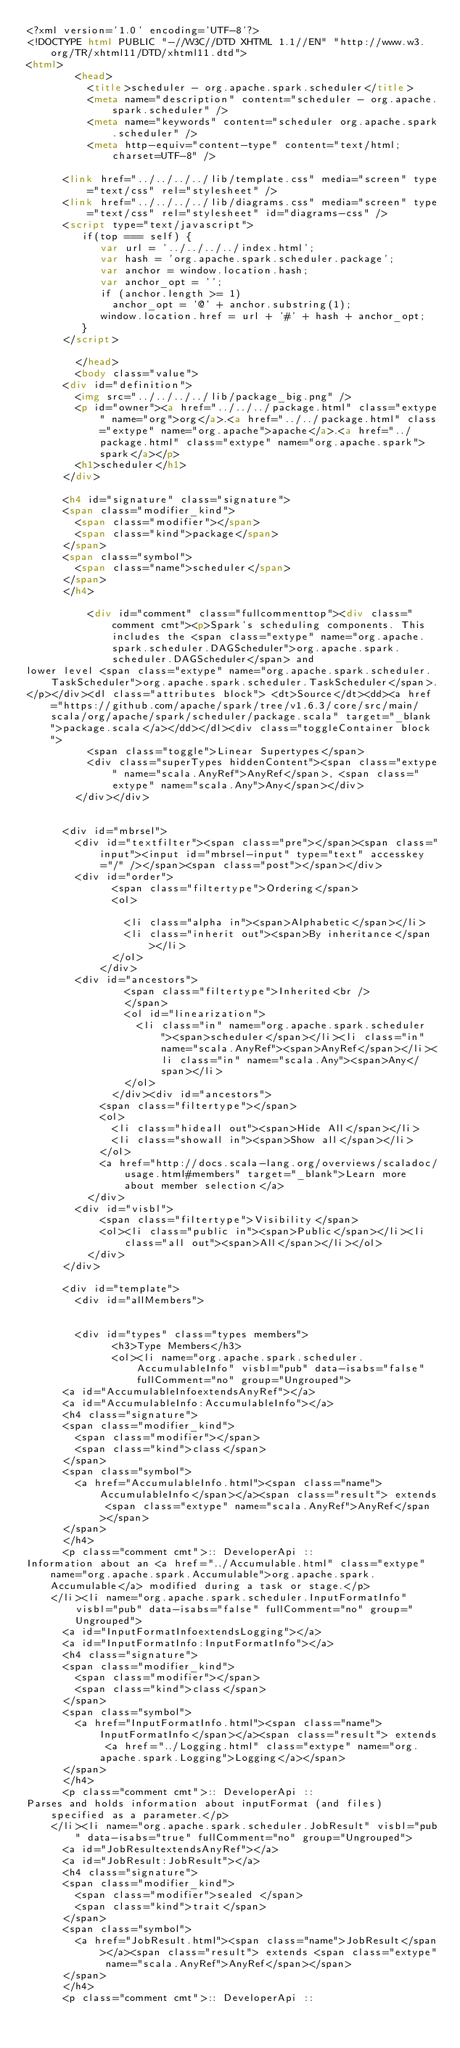Convert code to text. <code><loc_0><loc_0><loc_500><loc_500><_HTML_><?xml version='1.0' encoding='UTF-8'?>
<!DOCTYPE html PUBLIC "-//W3C//DTD XHTML 1.1//EN" "http://www.w3.org/TR/xhtml11/DTD/xhtml11.dtd">
<html>
        <head>
          <title>scheduler - org.apache.spark.scheduler</title>
          <meta name="description" content="scheduler - org.apache.spark.scheduler" />
          <meta name="keywords" content="scheduler org.apache.spark.scheduler" />
          <meta http-equiv="content-type" content="text/html; charset=UTF-8" />
          
      <link href="../../../../lib/template.css" media="screen" type="text/css" rel="stylesheet" />
      <link href="../../../../lib/diagrams.css" media="screen" type="text/css" rel="stylesheet" id="diagrams-css" />
      <script type="text/javascript">
         if(top === self) {
            var url = '../../../../index.html';
            var hash = 'org.apache.spark.scheduler.package';
            var anchor = window.location.hash;
            var anchor_opt = '';
            if (anchor.length >= 1)
              anchor_opt = '@' + anchor.substring(1);
            window.location.href = url + '#' + hash + anchor_opt;
         }
   	  </script>
    
        </head>
        <body class="value">
      <div id="definition">
        <img src="../../../../lib/package_big.png" />
        <p id="owner"><a href="../../../package.html" class="extype" name="org">org</a>.<a href="../../package.html" class="extype" name="org.apache">apache</a>.<a href="../package.html" class="extype" name="org.apache.spark">spark</a></p>
        <h1>scheduler</h1>
      </div>

      <h4 id="signature" class="signature">
      <span class="modifier_kind">
        <span class="modifier"></span>
        <span class="kind">package</span>
      </span>
      <span class="symbol">
        <span class="name">scheduler</span>
      </span>
      </h4>
      
          <div id="comment" class="fullcommenttop"><div class="comment cmt"><p>Spark's scheduling components. This includes the <span class="extype" name="org.apache.spark.scheduler.DAGScheduler">org.apache.spark.scheduler.DAGScheduler</span> and
lower level <span class="extype" name="org.apache.spark.scheduler.TaskScheduler">org.apache.spark.scheduler.TaskScheduler</span>.
</p></div><dl class="attributes block"> <dt>Source</dt><dd><a href="https://github.com/apache/spark/tree/v1.6.3/core/src/main/scala/org/apache/spark/scheduler/package.scala" target="_blank">package.scala</a></dd></dl><div class="toggleContainer block">
          <span class="toggle">Linear Supertypes</span>
          <div class="superTypes hiddenContent"><span class="extype" name="scala.AnyRef">AnyRef</span>, <span class="extype" name="scala.Any">Any</span></div>
        </div></div>
        

      <div id="mbrsel">
        <div id="textfilter"><span class="pre"></span><span class="input"><input id="mbrsel-input" type="text" accesskey="/" /></span><span class="post"></span></div>
        <div id="order">
              <span class="filtertype">Ordering</span>
              <ol>
                
                <li class="alpha in"><span>Alphabetic</span></li>
                <li class="inherit out"><span>By inheritance</span></li>
              </ol>
            </div>
        <div id="ancestors">
                <span class="filtertype">Inherited<br />
                </span>
                <ol id="linearization">
                  <li class="in" name="org.apache.spark.scheduler"><span>scheduler</span></li><li class="in" name="scala.AnyRef"><span>AnyRef</span></li><li class="in" name="scala.Any"><span>Any</span></li>
                </ol>
              </div><div id="ancestors">
            <span class="filtertype"></span>
            <ol>
              <li class="hideall out"><span>Hide All</span></li>
              <li class="showall in"><span>Show all</span></li>
            </ol>
            <a href="http://docs.scala-lang.org/overviews/scaladoc/usage.html#members" target="_blank">Learn more about member selection</a>
          </div>
        <div id="visbl">
            <span class="filtertype">Visibility</span>
            <ol><li class="public in"><span>Public</span></li><li class="all out"><span>All</span></li></ol>
          </div>
      </div>

      <div id="template">
        <div id="allMembers">
        

        <div id="types" class="types members">
              <h3>Type Members</h3>
              <ol><li name="org.apache.spark.scheduler.AccumulableInfo" visbl="pub" data-isabs="false" fullComment="no" group="Ungrouped">
      <a id="AccumulableInfoextendsAnyRef"></a>
      <a id="AccumulableInfo:AccumulableInfo"></a>
      <h4 class="signature">
      <span class="modifier_kind">
        <span class="modifier"></span>
        <span class="kind">class</span>
      </span>
      <span class="symbol">
        <a href="AccumulableInfo.html"><span class="name">AccumulableInfo</span></a><span class="result"> extends <span class="extype" name="scala.AnyRef">AnyRef</span></span>
      </span>
      </h4>
      <p class="comment cmt">:: DeveloperApi ::
Information about an <a href="../Accumulable.html" class="extype" name="org.apache.spark.Accumulable">org.apache.spark.Accumulable</a> modified during a task or stage.</p>
    </li><li name="org.apache.spark.scheduler.InputFormatInfo" visbl="pub" data-isabs="false" fullComment="no" group="Ungrouped">
      <a id="InputFormatInfoextendsLogging"></a>
      <a id="InputFormatInfo:InputFormatInfo"></a>
      <h4 class="signature">
      <span class="modifier_kind">
        <span class="modifier"></span>
        <span class="kind">class</span>
      </span>
      <span class="symbol">
        <a href="InputFormatInfo.html"><span class="name">InputFormatInfo</span></a><span class="result"> extends <a href="../Logging.html" class="extype" name="org.apache.spark.Logging">Logging</a></span>
      </span>
      </h4>
      <p class="comment cmt">:: DeveloperApi ::
Parses and holds information about inputFormat (and files) specified as a parameter.</p>
    </li><li name="org.apache.spark.scheduler.JobResult" visbl="pub" data-isabs="true" fullComment="no" group="Ungrouped">
      <a id="JobResultextendsAnyRef"></a>
      <a id="JobResult:JobResult"></a>
      <h4 class="signature">
      <span class="modifier_kind">
        <span class="modifier">sealed </span>
        <span class="kind">trait</span>
      </span>
      <span class="symbol">
        <a href="JobResult.html"><span class="name">JobResult</span></a><span class="result"> extends <span class="extype" name="scala.AnyRef">AnyRef</span></span>
      </span>
      </h4>
      <p class="comment cmt">:: DeveloperApi ::</code> 